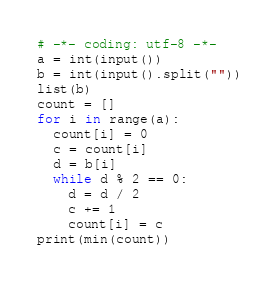<code> <loc_0><loc_0><loc_500><loc_500><_Python_># -*- coding: utf-8 -*-
a = int(input())
b = int(input().split(""))
list(b)
count = []
for i in range(a):
  count[i] = 0
  c = count[i]
  d = b[i]
  while d % 2 == 0:
    d = d / 2
    c += 1
    count[i] = c
print(min(count))</code> 